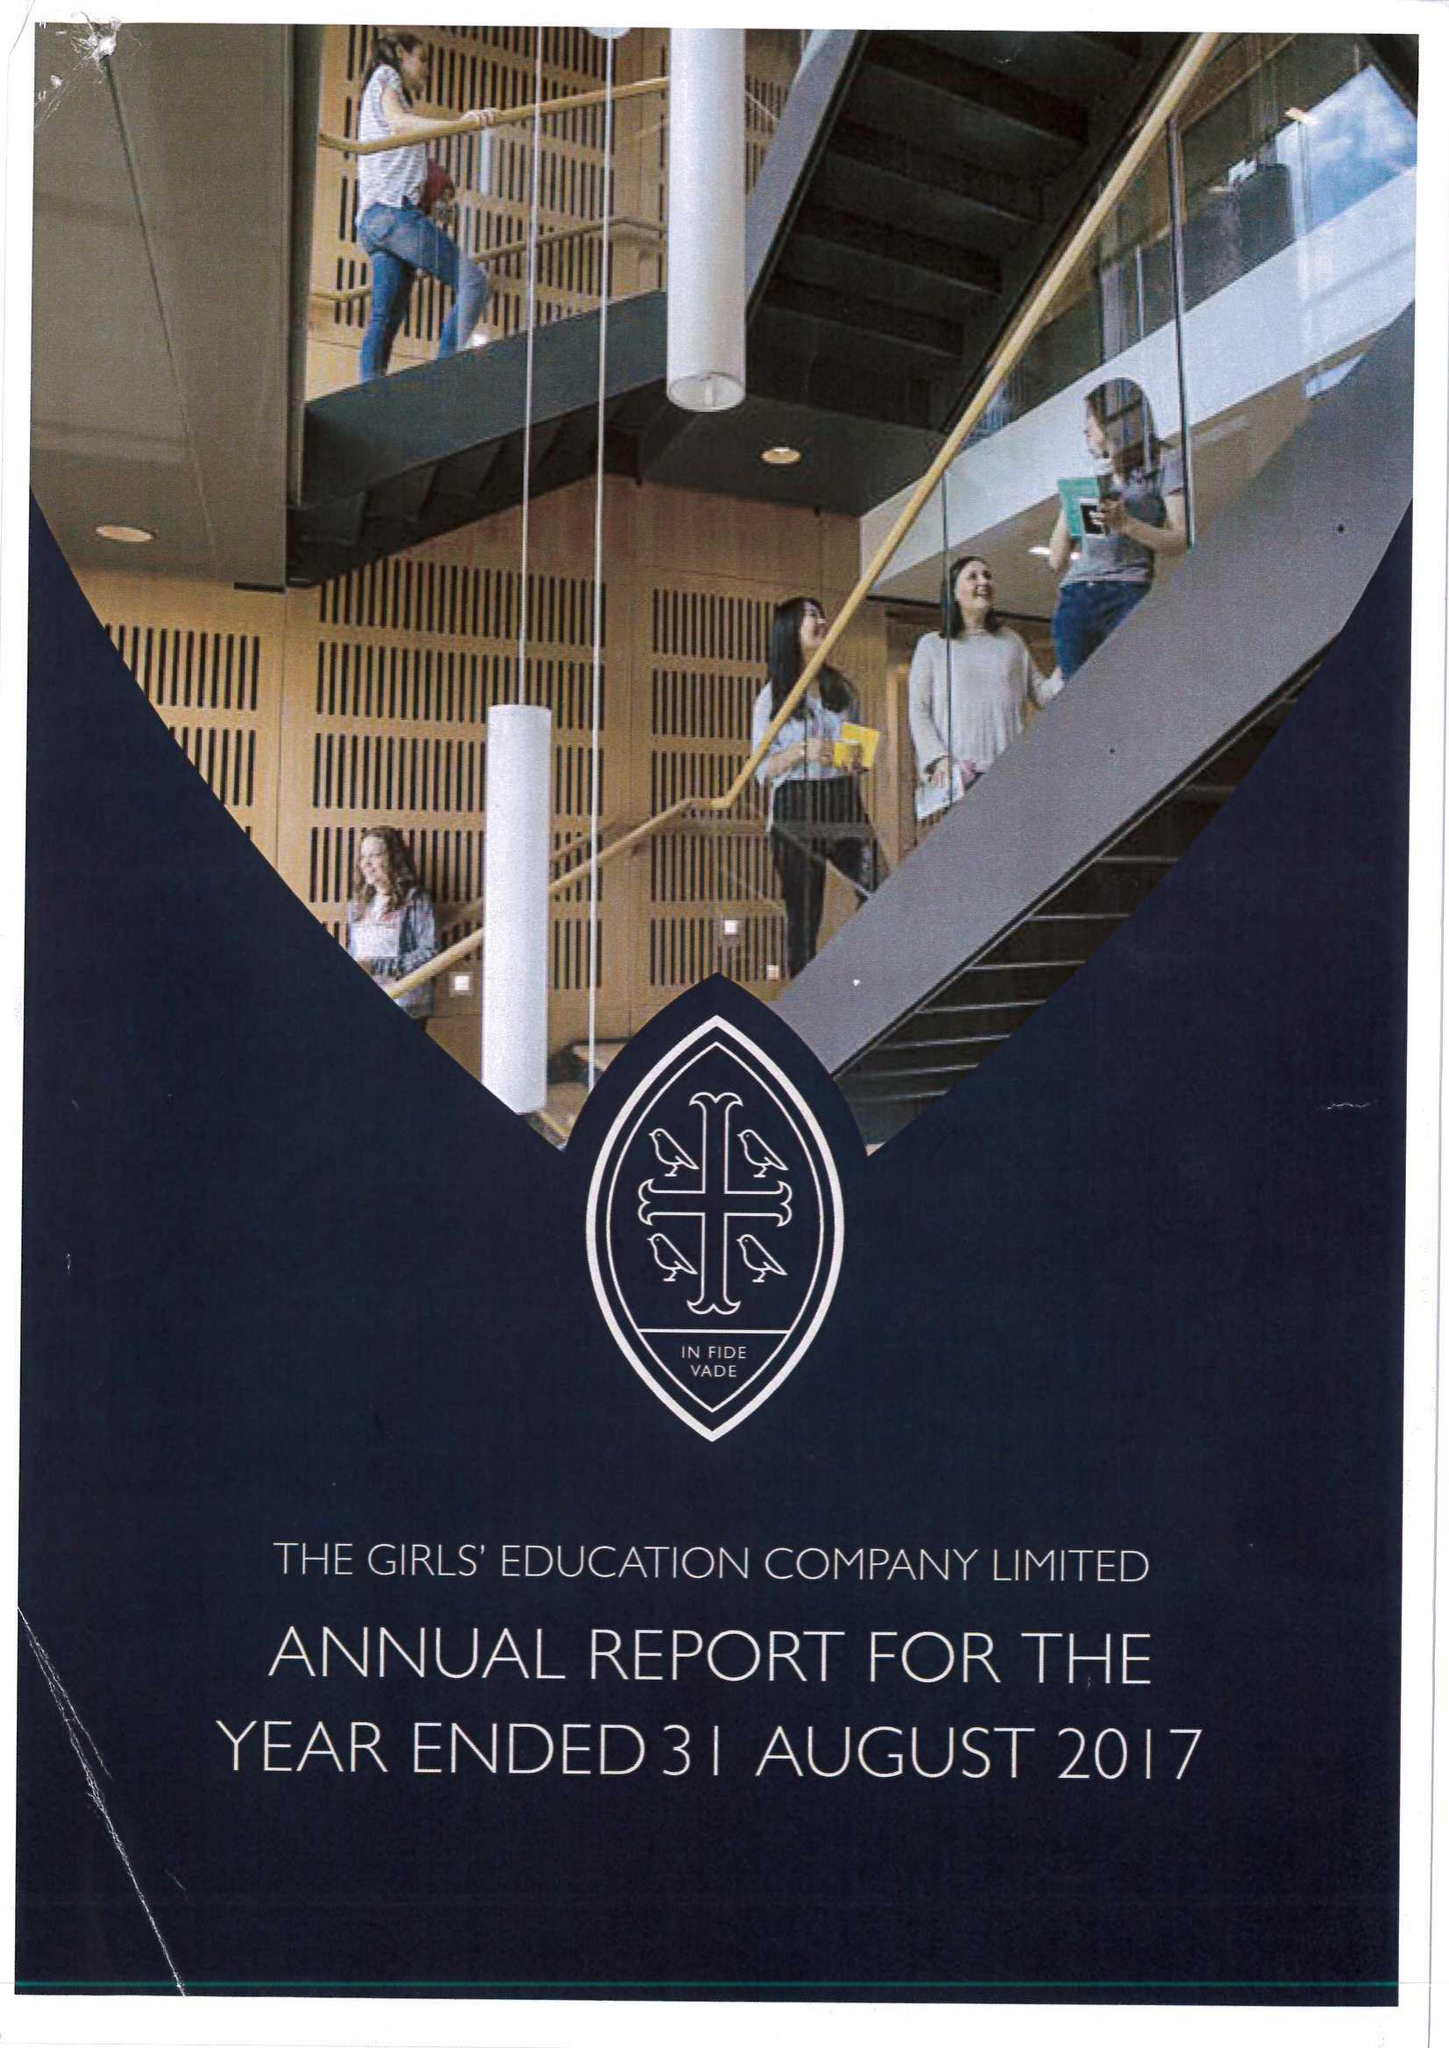What is the value for the charity_name?
Answer the question using a single word or phrase. Girls' Education Company Ltd. 